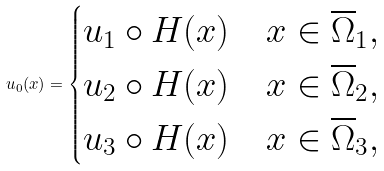Convert formula to latex. <formula><loc_0><loc_0><loc_500><loc_500>u _ { 0 } ( x ) = \begin{cases} u _ { 1 } \circ H ( x ) \quad x \in \overline { \Omega } _ { 1 } , \\ u _ { 2 } \circ H ( x ) \quad x \in \overline { \Omega } _ { 2 } , \\ u _ { 3 } \circ H ( x ) \quad x \in \overline { \Omega } _ { 3 } , \end{cases}</formula> 